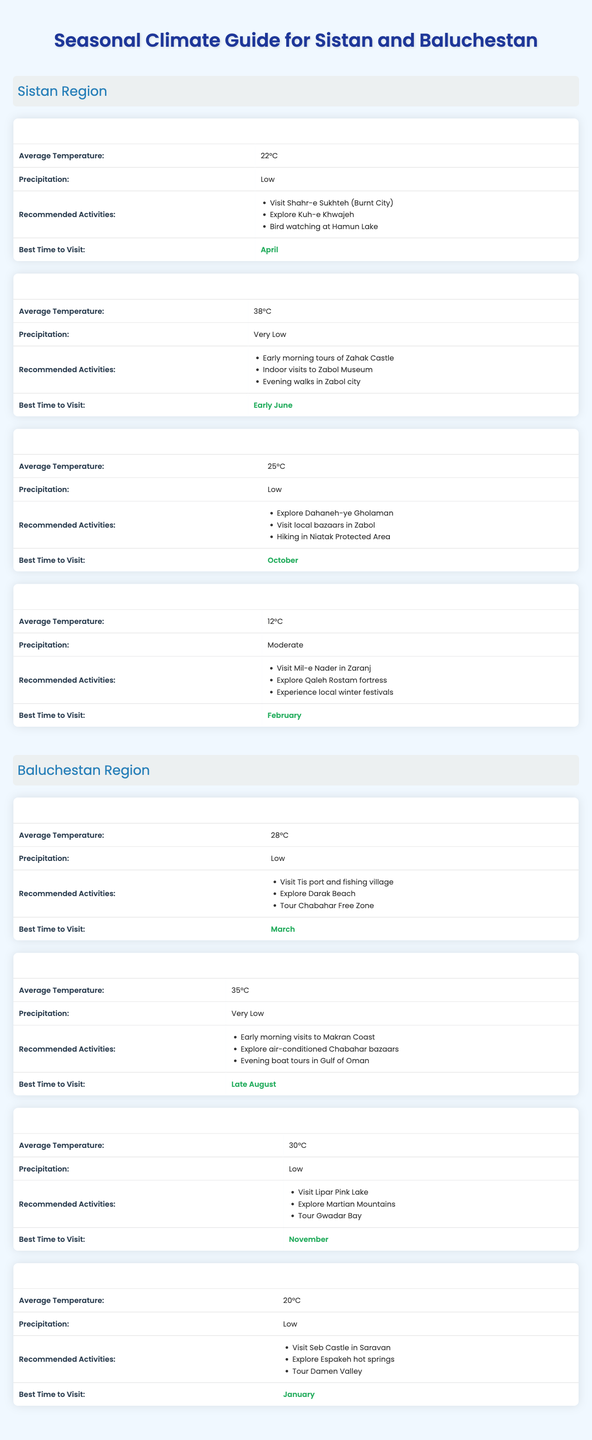What is the average temperature in the Sistan region during Autumn? The table shows that the average temperature for the Autumn season in the Sistan region is 25°C.
Answer: 25°C Which season has the lowest average temperature in the Baluchestan region? The Winter season in the Baluchestan region has an average temperature of 20°C, which is lower than other seasons.
Answer: Winter Is the recommended time to visit the Baluchestan region during Spring different from the best time in the Sistan region in Spring? The best time to visit the Baluchestan region in Spring is March, while the best time for the Sistan region in Spring is April, so they are different.
Answer: Yes During which season should a visitor avoid Sistan and Baluchestan due to high temperatures? The Summer season has the highest temperatures, reaching 38°C in Sistan and 35°C in Baluchestan, making it a less recommended time for visiting due to heat.
Answer: Summer What activities are recommended in the Sistan region during Winter? The table lists visiting Mil-e Nader, exploring Qaleh Rostam fortress, and experiencing local winter festivals as recommended activities in Winter for the Sistan region.
Answer: Visit Mil-e Nader, explore Qaleh Rostam, experience winter festivals How does the average temperature in Spring compare to Winter in the Sistan region? In Spring, the average temperature is 22°C, while in Winter it is 12°C. The difference shows that Spring is significantly warmer than Winter by 10°C.
Answer: 10°C warmer Are there any activities to do during the Summer season in the Baluchestan region? Yes, the table lists early morning visits to Makran Coast, exploring air-conditioned Chabahar bazaars, and evening boat tours in the Gulf of Oman as recommended activities.
Answer: Yes Which region has a higher average temperature during Autumn? The Sistan region has an average temperature of 25°C, while Baluchestan has 30°C during Autumn, showing that Baluchestan is warmer.
Answer: Baluchestan What is the precipitation level in the Baluchestan region during Winter? The table indicates that the precipitation in the Baluchestan region during Winter is low.
Answer: Low Which activities are suggested for tourists in the Spring season in the Sistan region? The table recommends visiting Shahr-e Sukhteh, exploring Kuh-e Khwajeh, and bird watching at Hamun Lake for the Spring season in the Sistan region.
Answer: Visit Shahr-e Sukhteh, explore Kuh-e Khwajeh, bird watching at Hamun Lake 